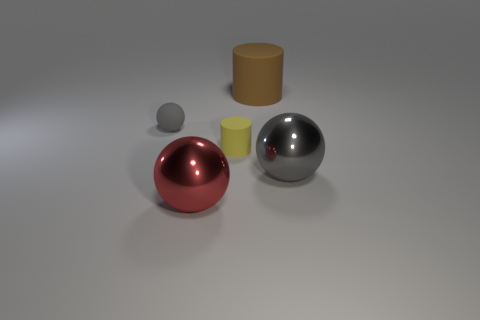What number of other things are the same color as the small sphere?
Offer a terse response. 1. What color is the big metallic object that is to the left of the large brown rubber cylinder?
Give a very brief answer. Red. How many other things are there of the same material as the big red thing?
Provide a succinct answer. 1. Are there more metallic spheres behind the tiny yellow rubber cylinder than large gray metallic spheres that are behind the large rubber cylinder?
Provide a succinct answer. No. What number of cylinders are in front of the tiny gray matte ball?
Your answer should be very brief. 1. Are the big cylinder and the gray ball on the right side of the tiny rubber sphere made of the same material?
Your response must be concise. No. Is there any other thing that has the same shape as the red object?
Your answer should be compact. Yes. Are the small gray object and the big brown object made of the same material?
Offer a terse response. Yes. Is there a small gray thing on the left side of the thing that is to the left of the red metal object?
Ensure brevity in your answer.  No. How many large shiny balls are both left of the brown cylinder and right of the large cylinder?
Your response must be concise. 0. 